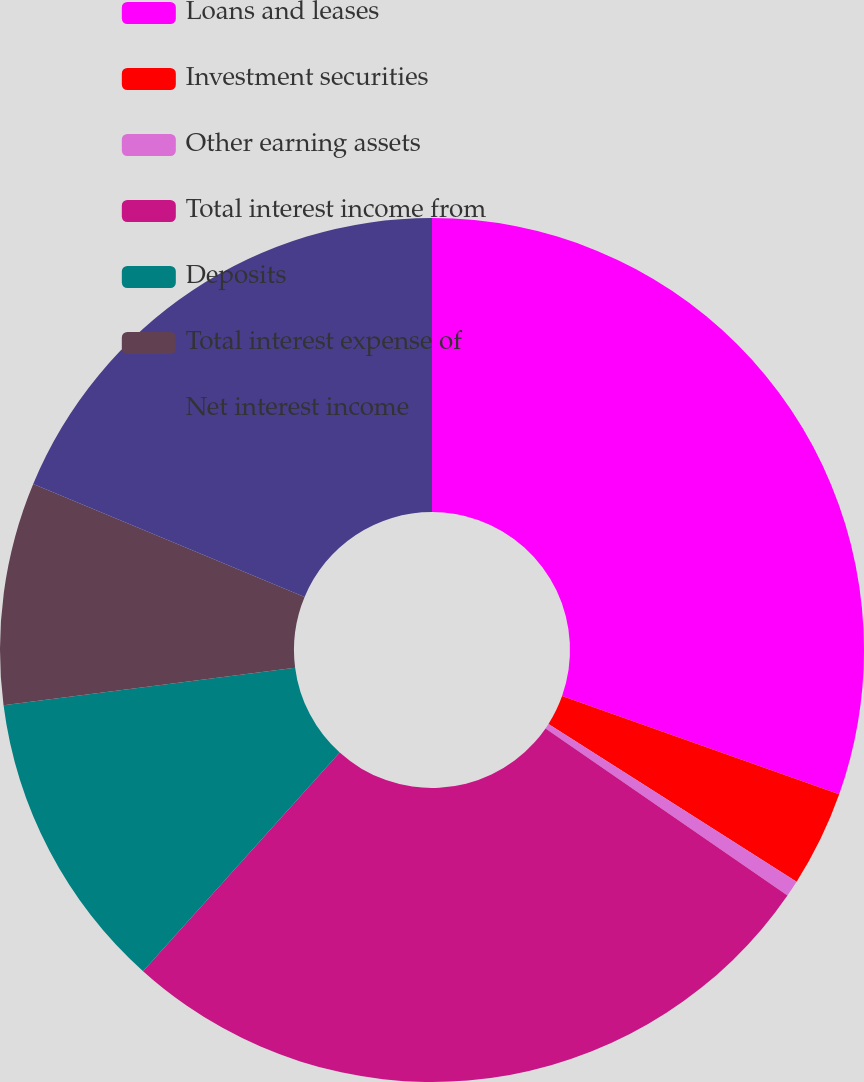<chart> <loc_0><loc_0><loc_500><loc_500><pie_chart><fcel>Loans and leases<fcel>Investment securities<fcel>Other earning assets<fcel>Total interest income from<fcel>Deposits<fcel>Total interest expense of<fcel>Net interest income<nl><fcel>30.42%<fcel>3.59%<fcel>0.61%<fcel>27.04%<fcel>11.3%<fcel>8.32%<fcel>18.72%<nl></chart> 